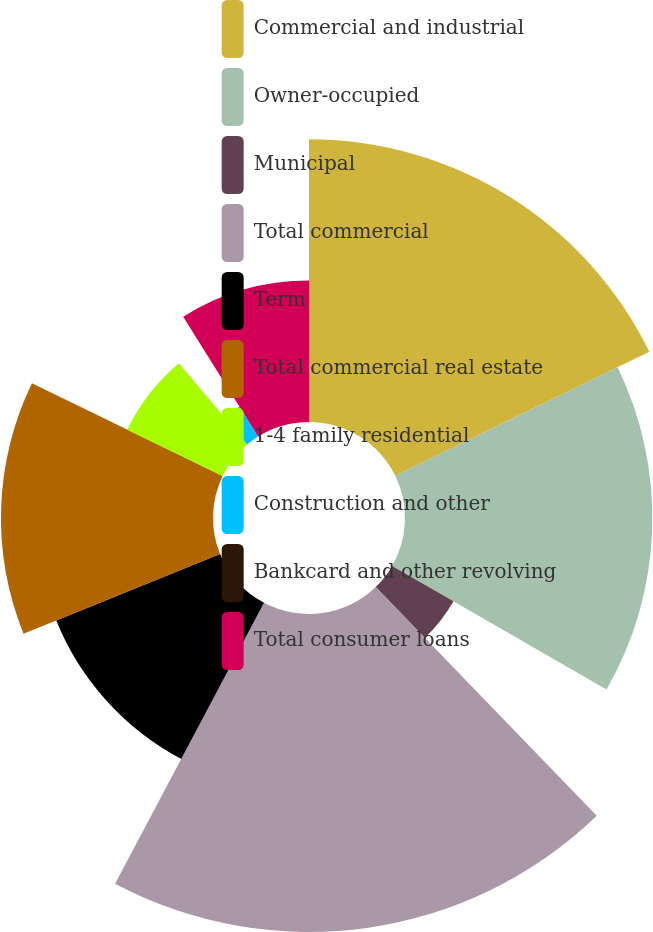Convert chart. <chart><loc_0><loc_0><loc_500><loc_500><pie_chart><fcel>Commercial and industrial<fcel>Owner-occupied<fcel>Municipal<fcel>Total commercial<fcel>Term<fcel>Total commercial real estate<fcel>1-4 family residential<fcel>Construction and other<fcel>Bankcard and other revolving<fcel>Total consumer loans<nl><fcel>17.77%<fcel>15.55%<fcel>4.45%<fcel>19.99%<fcel>11.11%<fcel>13.33%<fcel>6.67%<fcel>2.23%<fcel>0.01%<fcel>8.89%<nl></chart> 